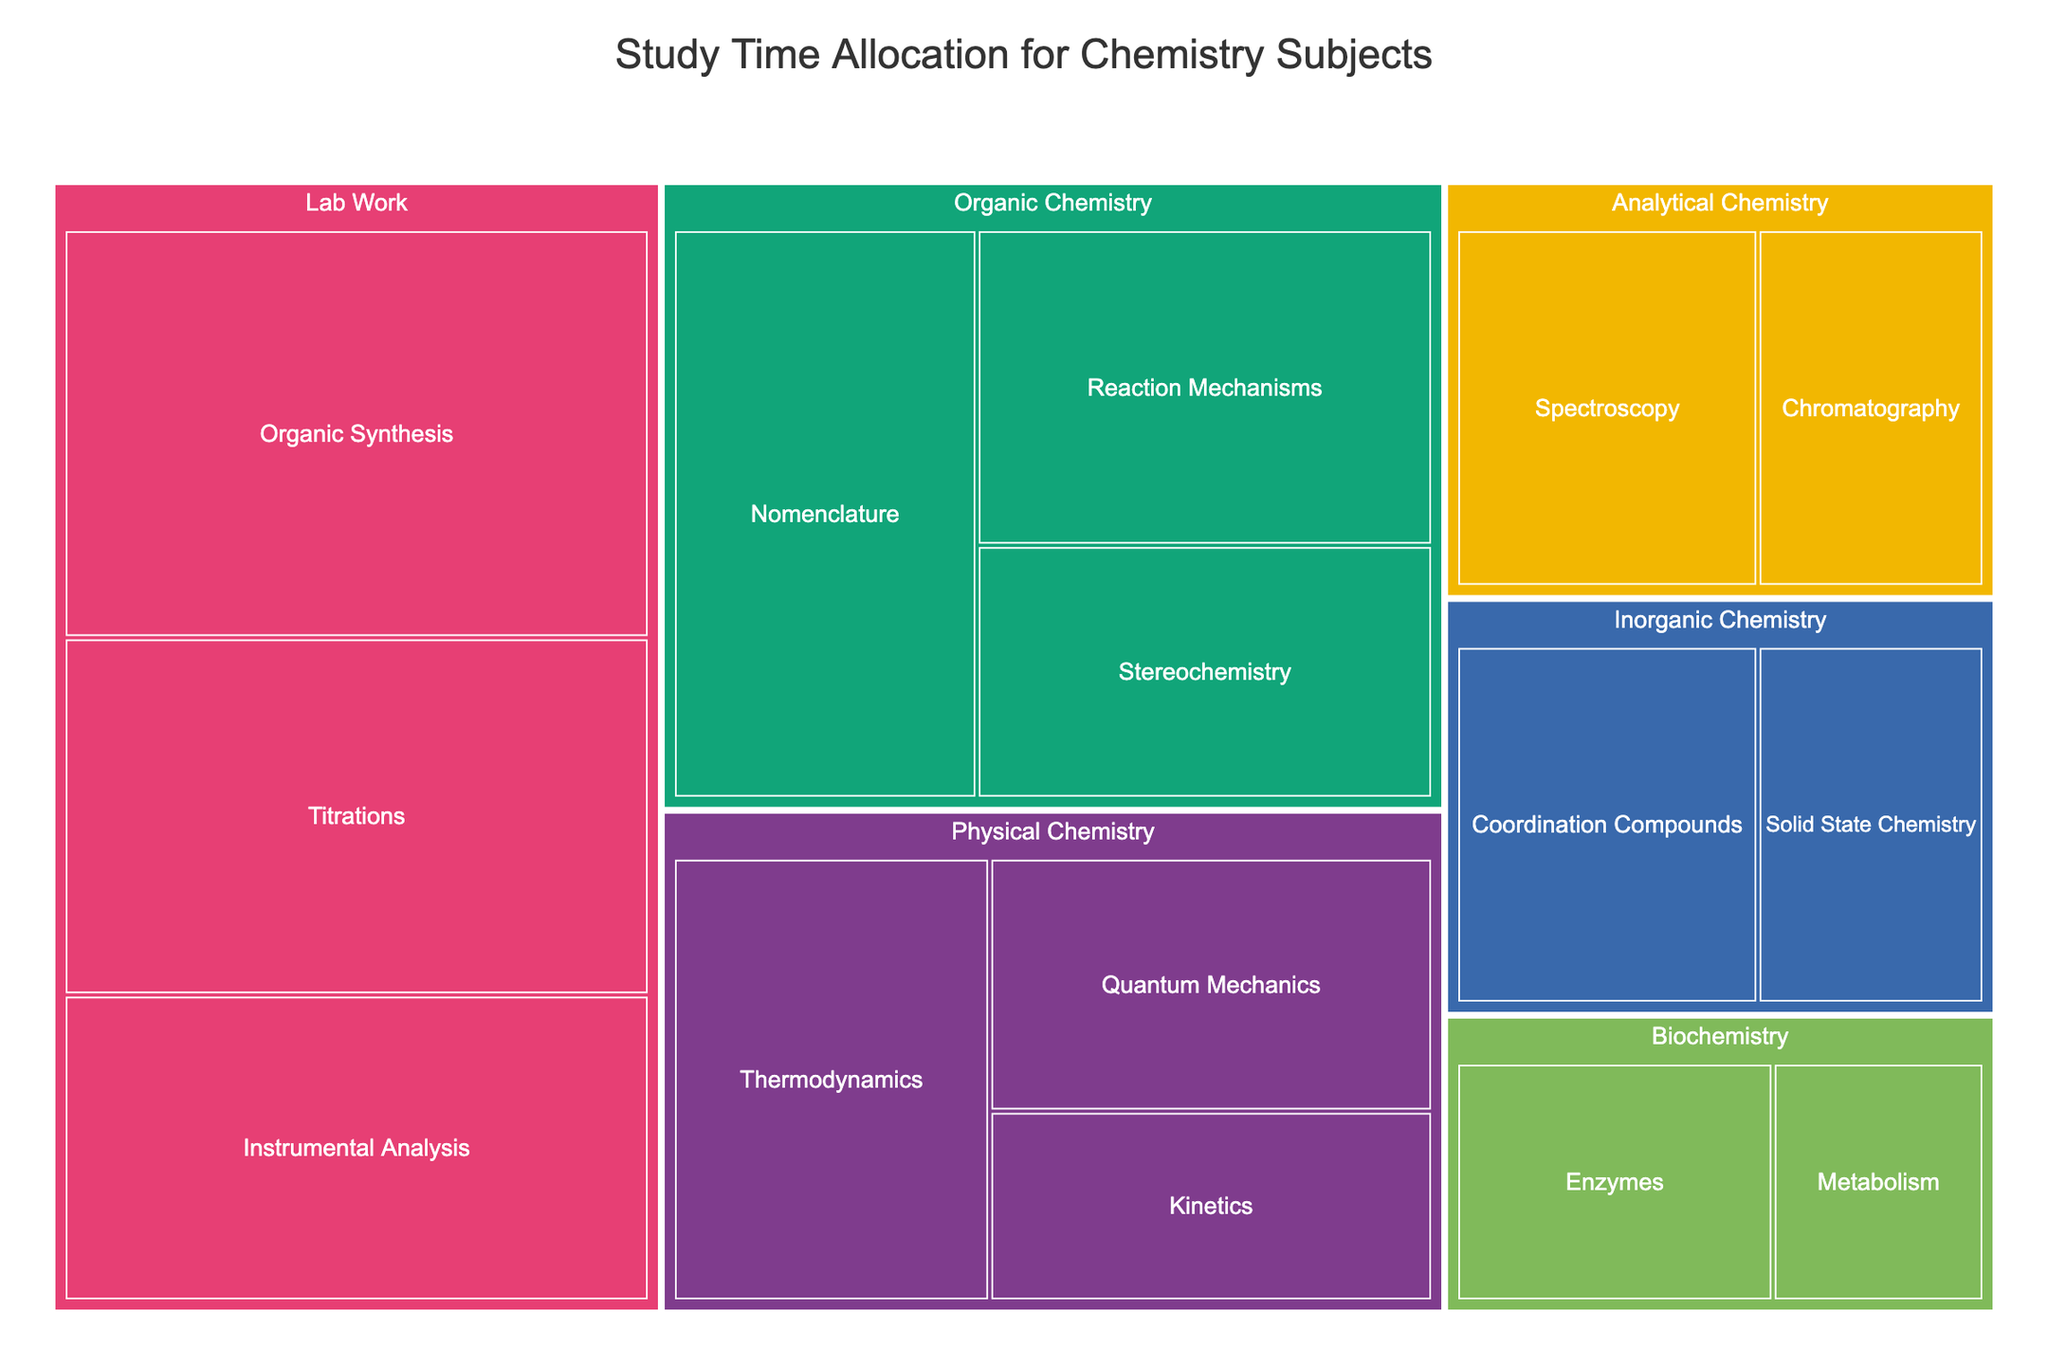What's the total time allocated to Organic Chemistry? To find the total time allocated to Organic Chemistry, sum the hours of its subtopics: 30 hours (Nomenclature) + 25 hours (Reaction Mechanisms) + 20 hours (Stereochemistry).
Answer: 75 hours Which subject has the highest total study time? Compare the total study times of all subjects. Organic Chemistry has 75 hours, Inorganic Chemistry has 35 hours, Physical Chemistry has 60 hours, Analytical Chemistry has 35 hours, Biochemistry has 25 hours, and Lab Work has 105 hours.
Answer: Lab Work What is the difference in study time between Organic Chemistry and Physical Chemistry? First, find the total study time for each subject: Organic Chemistry has 75 hours, and Physical Chemistry has 60 hours. The difference is 75 - 60.
Answer: 15 hours Which subtopic within Lab Work has the most study time? Look within the Lab Work category, which includes Organic Synthesis (40 hours), Titrations (35 hours), and Instrumental Analysis (30 hours).
Answer: Organic Synthesis How much time is spent on the Quantum Mechanics subtopic in Physical Chemistry? Find the Quantum Mechanics subtopic within the Physical Chemistry category. It is allocated 20 hours.
Answer: 20 hours What's the total time allocated to all subjects? Sum the times for all subjects: 75 hours (Organic Chemistry) + 35 hours (Inorganic Chemistry) + 60 hours (Physical Chemistry) + 35 hours (Analytical Chemistry) + 25 hours (Biochemistry) + 105 hours (Lab Work).
Answer: 335 hours Which subtopic in Analytical Chemistry has less allocated time? Compare the times within Analytical Chemistry: Spectroscopy (20 hours) and Chromatography (15 hours).
Answer: Chromatography Is the time allocated to Inorganic Chemistry more or less than the time allocated to Biochemistry? Inorganic Chemistry has 35 hours in total, while Biochemistry has 25 hours.
Answer: More What's the average study time for subtopics in Physical Chemistry? The study times for Physical Chemistry subtopics are 25 hours (Thermodynamics), 20 hours (Quantum Mechanics), and 15 hours (Kinetics). The average is (25 + 20 + 15)/3.
Answer: 20 hours Which subject has the least study time allocated? Compare the total study times for all subjects. Biochemistry has the least time, with 25 hours.
Answer: Biochemistry 